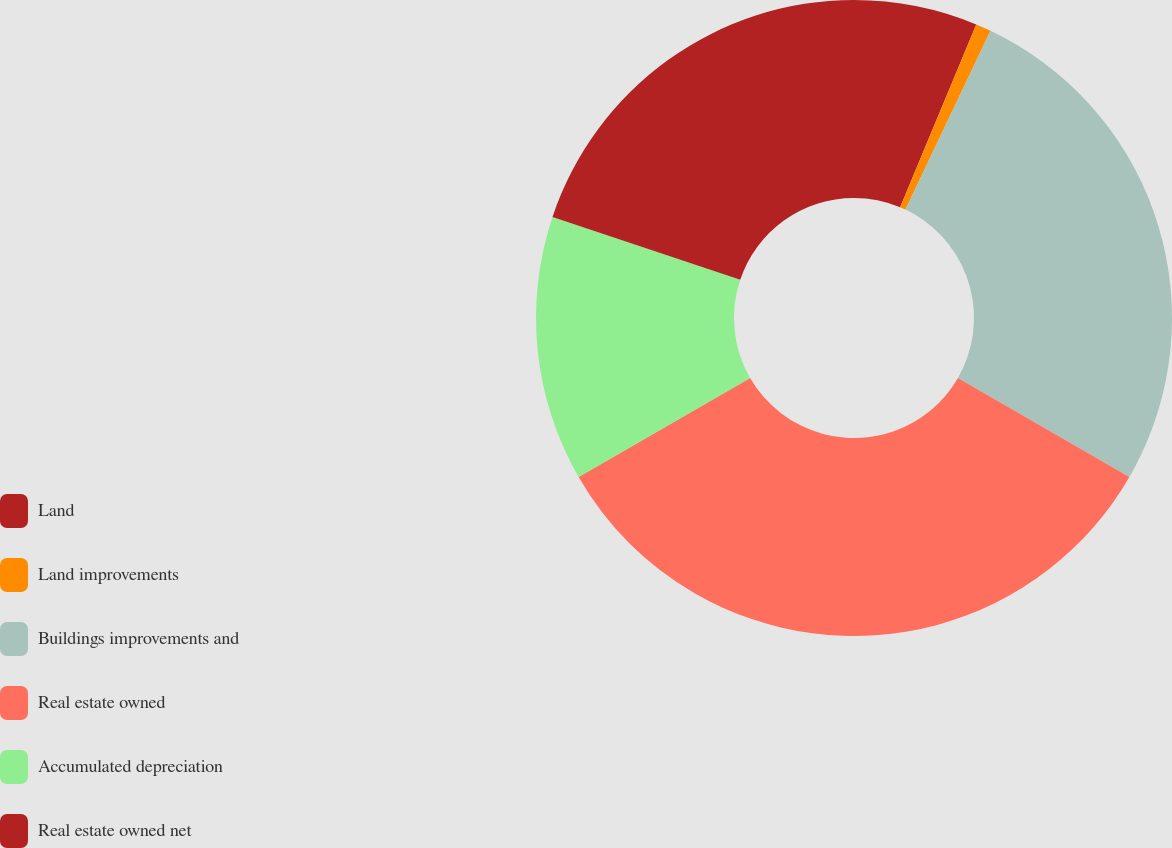Convert chart. <chart><loc_0><loc_0><loc_500><loc_500><pie_chart><fcel>Land<fcel>Land improvements<fcel>Buildings improvements and<fcel>Real estate owned<fcel>Accumulated depreciation<fcel>Real estate owned net<nl><fcel>6.28%<fcel>0.78%<fcel>26.27%<fcel>33.33%<fcel>13.48%<fcel>19.85%<nl></chart> 